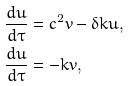Convert formula to latex. <formula><loc_0><loc_0><loc_500><loc_500>\frac { d u } { d \tau } & = c ^ { 2 } v - \delta k u , \\ \frac { d u } { d \tau } & = - k v ,</formula> 